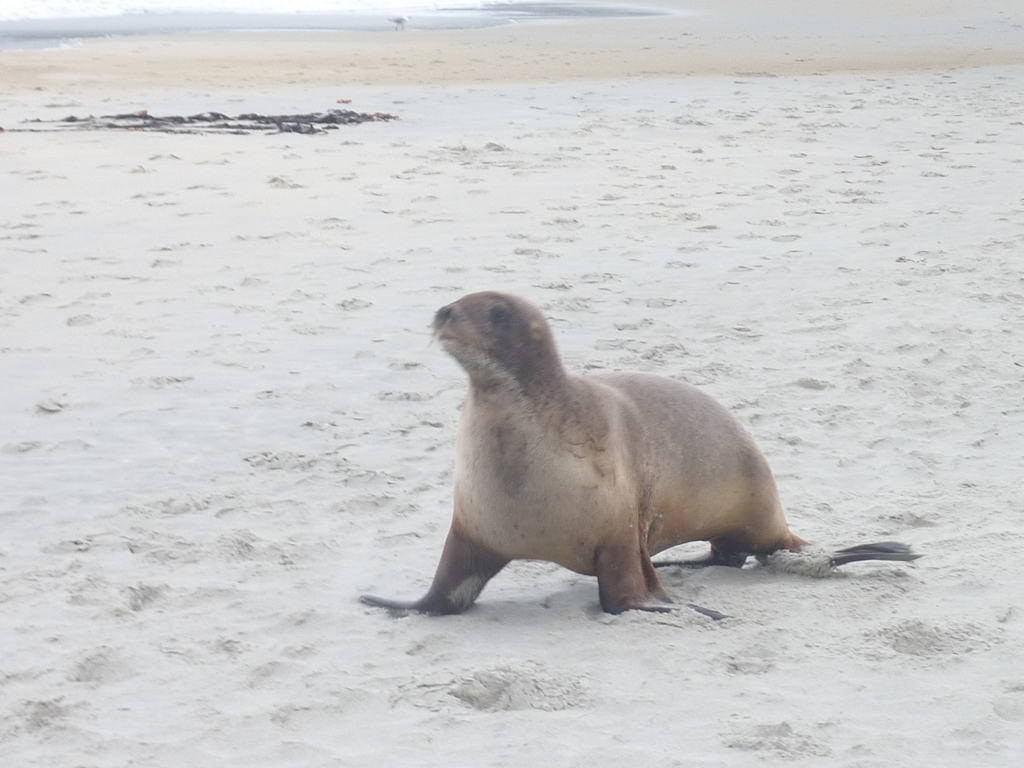What time of day does it appear to be in the image? Given the diffused lighting and the lack of strong shadows, it could be either an overcast day or a time close to sunrise or sunset. The precise time of day is not clear from the image alone. 